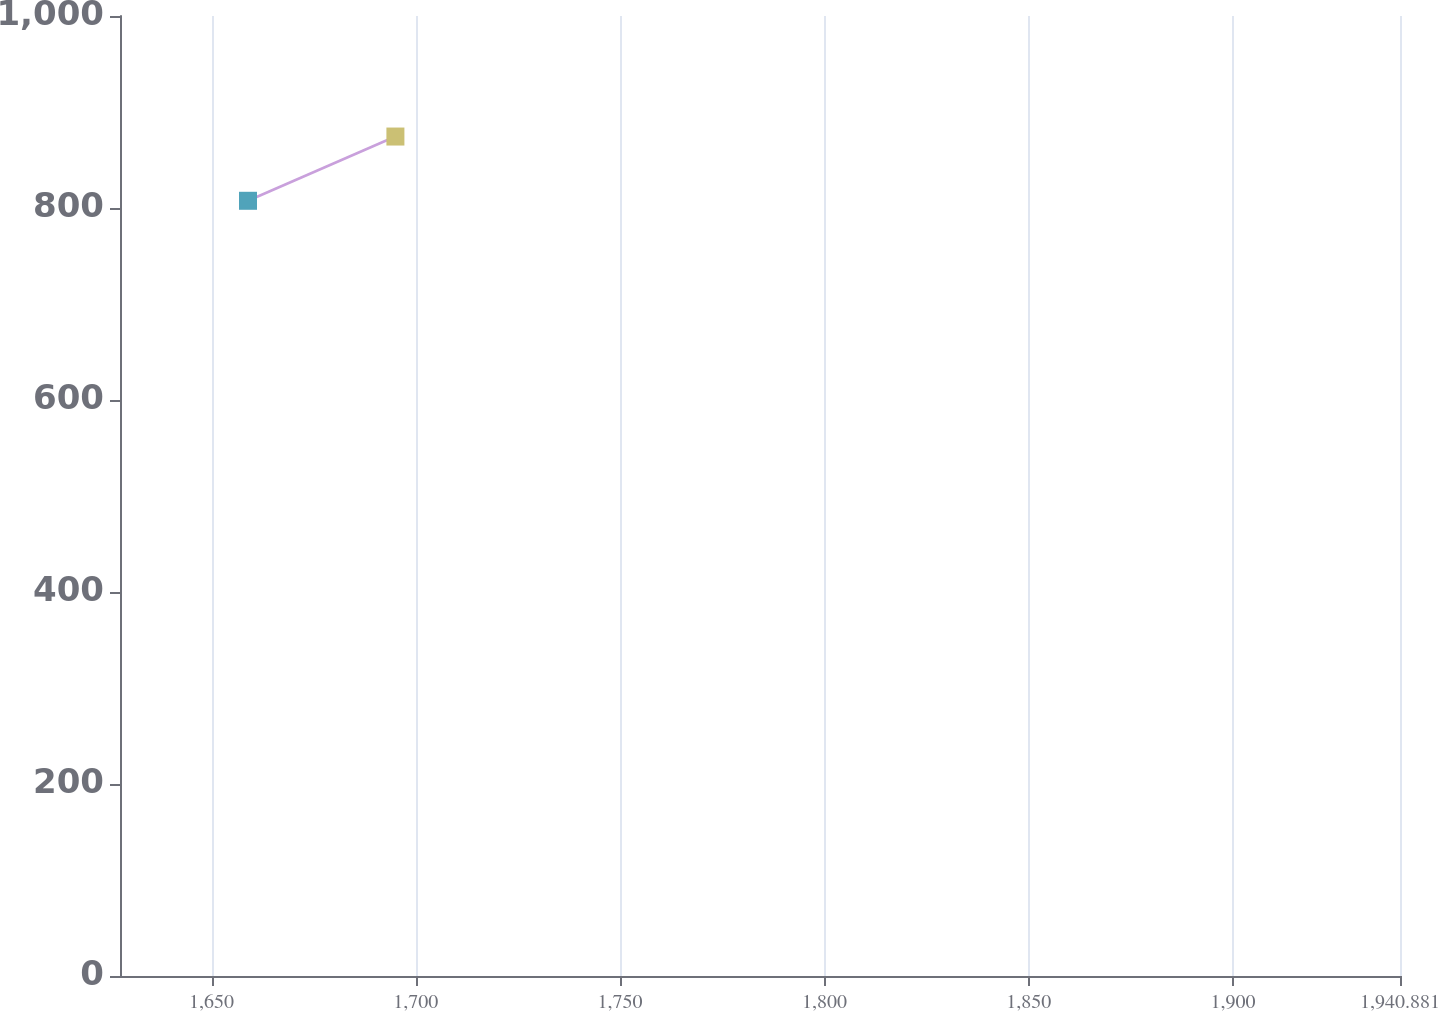Convert chart. <chart><loc_0><loc_0><loc_500><loc_500><line_chart><ecel><fcel>$ 691.6<nl><fcel>1658.92<fcel>807.51<nl><fcel>1695<fcel>874.44<nl><fcel>1972.21<fcel>974.51<nl></chart> 